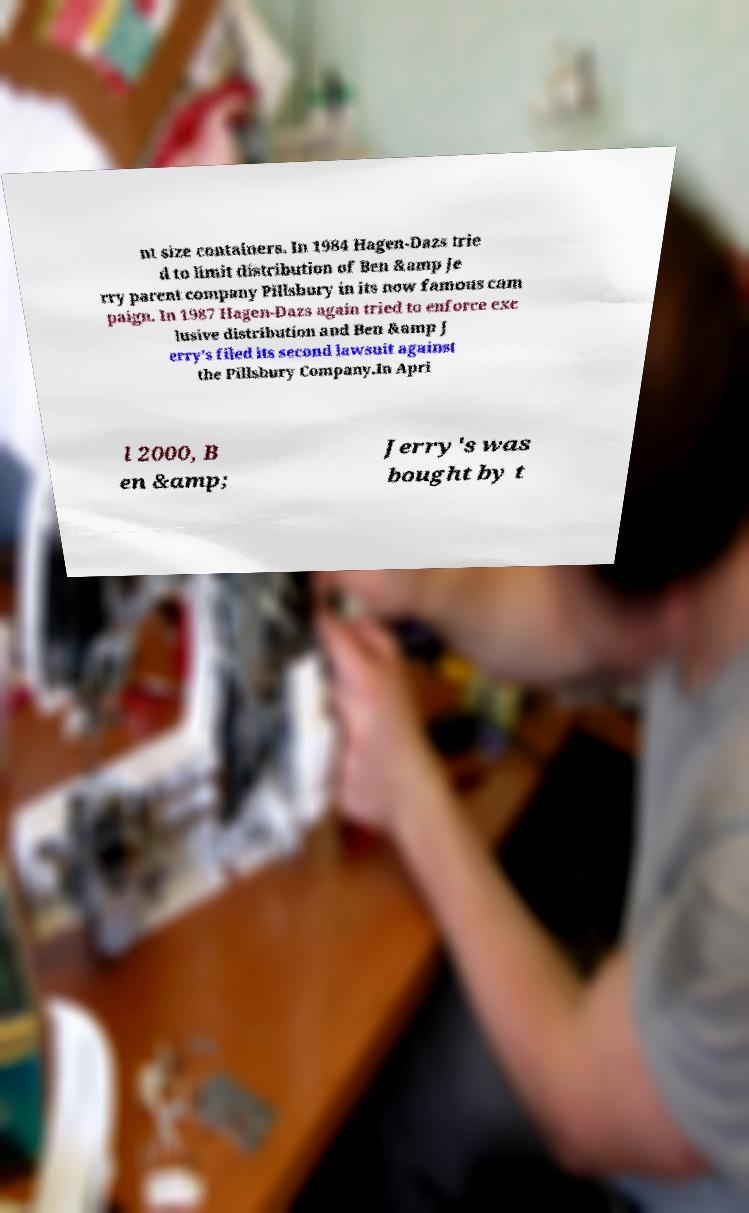Can you read and provide the text displayed in the image?This photo seems to have some interesting text. Can you extract and type it out for me? nt size containers. In 1984 Hagen-Dazs trie d to limit distribution of Ben &amp Je rry parent company Pillsbury in its now famous cam paign. In 1987 Hagen-Dazs again tried to enforce exc lusive distribution and Ben &amp J erry’s filed its second lawsuit against the Pillsbury Company.In Apri l 2000, B en &amp; Jerry's was bought by t 